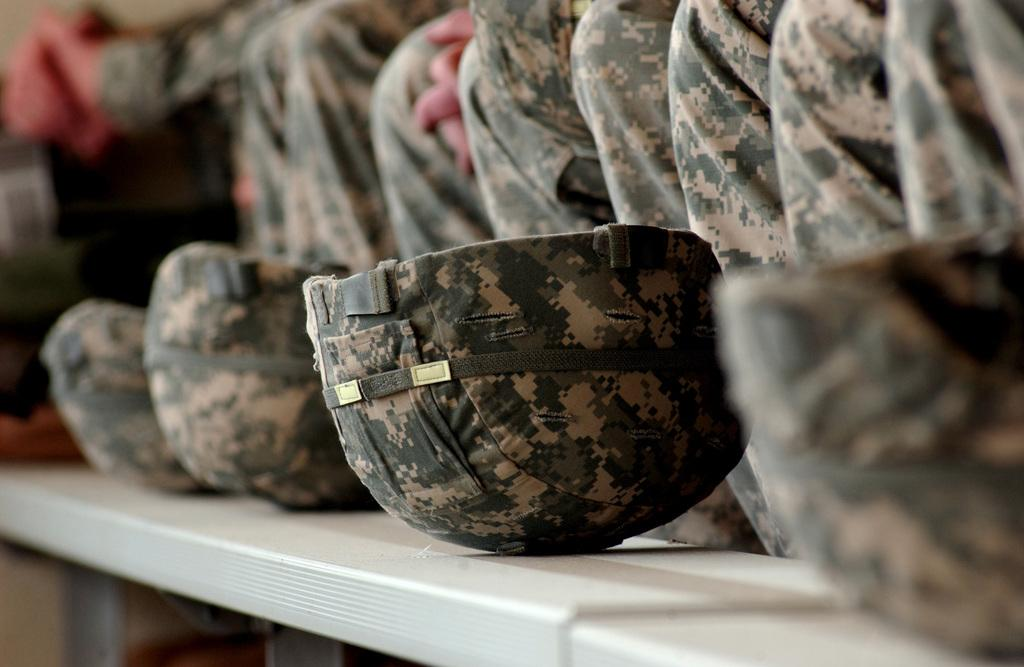What is located in the center of the image? There are caps in the center of the image. Where are the persons situated in the image? The persons are on the right side of the image. Can you describe the background of the image? The background of the image is blurry. How many family members are present in the image? There is no information about family members in the image; it only mentions caps and persons. What type of ring can be seen on the person's finger in the image? There is no ring visible on any person's finger in the image. 